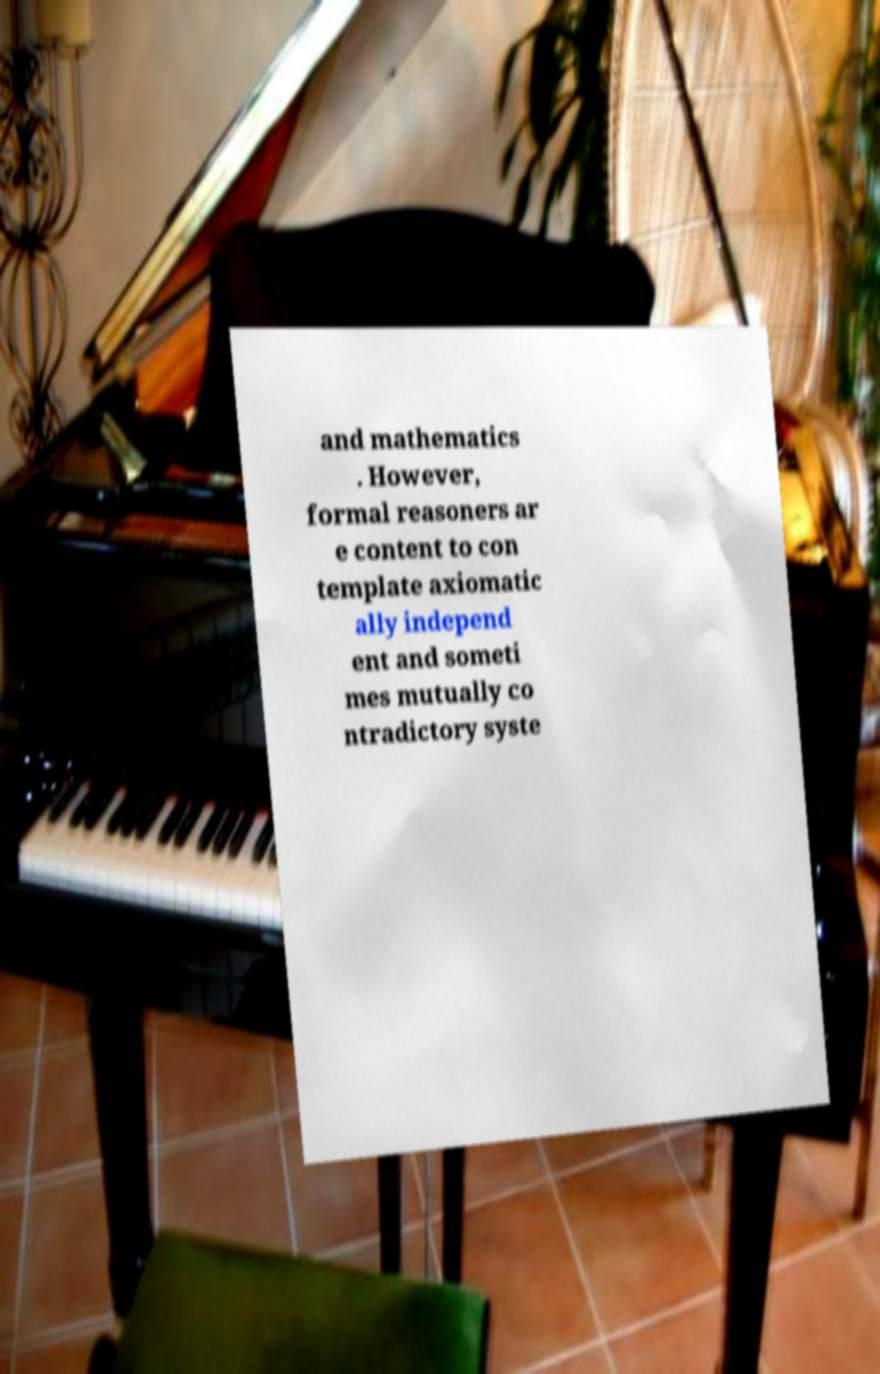Can you read and provide the text displayed in the image?This photo seems to have some interesting text. Can you extract and type it out for me? and mathematics . However, formal reasoners ar e content to con template axiomatic ally independ ent and someti mes mutually co ntradictory syste 